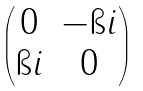<formula> <loc_0><loc_0><loc_500><loc_500>\begin{pmatrix} 0 & - \i i \\ \i i & 0 \end{pmatrix}</formula> 